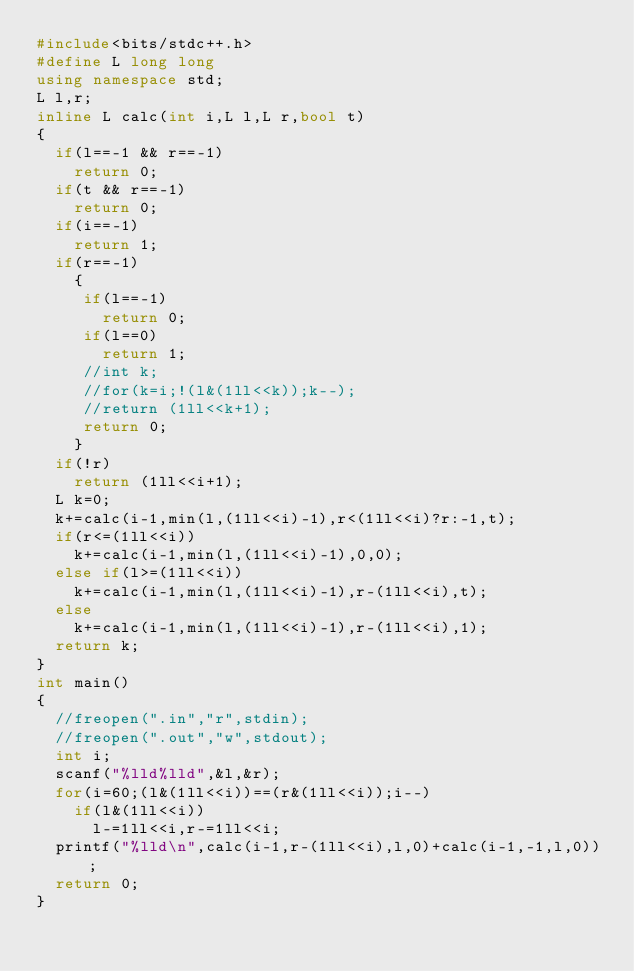<code> <loc_0><loc_0><loc_500><loc_500><_C++_>#include<bits/stdc++.h>
#define L long long
using namespace std;
L l,r;
inline L calc(int i,L l,L r,bool t)
{
	if(l==-1 && r==-1)
	  return 0;
	if(t && r==-1)
	  return 0;
	if(i==-1)
	  return 1;
	if(r==-1)
	  {
	   if(l==-1)
	     return 0;
	   if(l==0)
	     return 1;
	   //int k;
	   //for(k=i;!(l&(1ll<<k));k--);
	   //return (1ll<<k+1);
	   return 0;
	  }
	if(!r)
	  return (1ll<<i+1);
	L k=0;
	k+=calc(i-1,min(l,(1ll<<i)-1),r<(1ll<<i)?r:-1,t);
	if(r<=(1ll<<i))
	  k+=calc(i-1,min(l,(1ll<<i)-1),0,0);
	else if(l>=(1ll<<i))
	  k+=calc(i-1,min(l,(1ll<<i)-1),r-(1ll<<i),t);
	else
	  k+=calc(i-1,min(l,(1ll<<i)-1),r-(1ll<<i),1);
	return k;
}
int main()
{
	//freopen(".in","r",stdin);
	//freopen(".out","w",stdout);
	int i;
	scanf("%lld%lld",&l,&r);
	for(i=60;(l&(1ll<<i))==(r&(1ll<<i));i--)
	  if(l&(1ll<<i))
	    l-=1ll<<i,r-=1ll<<i;
	printf("%lld\n",calc(i-1,r-(1ll<<i),l,0)+calc(i-1,-1,l,0));
	return 0;
}
</code> 